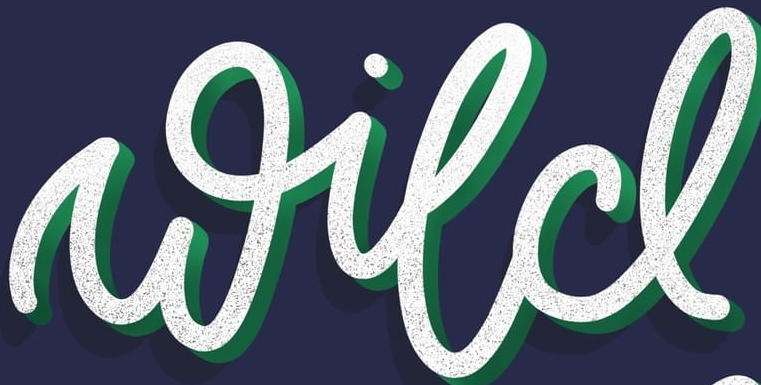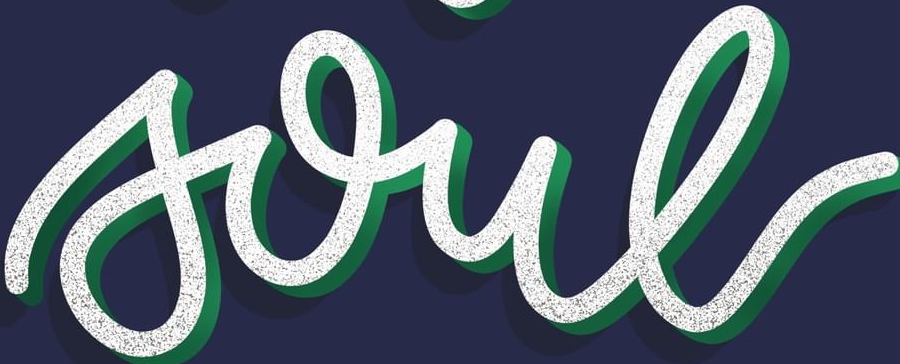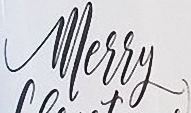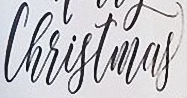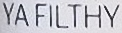What words are shown in these images in order, separated by a semicolon? wild; soul; Merry; Christmas; YAFILTHY 